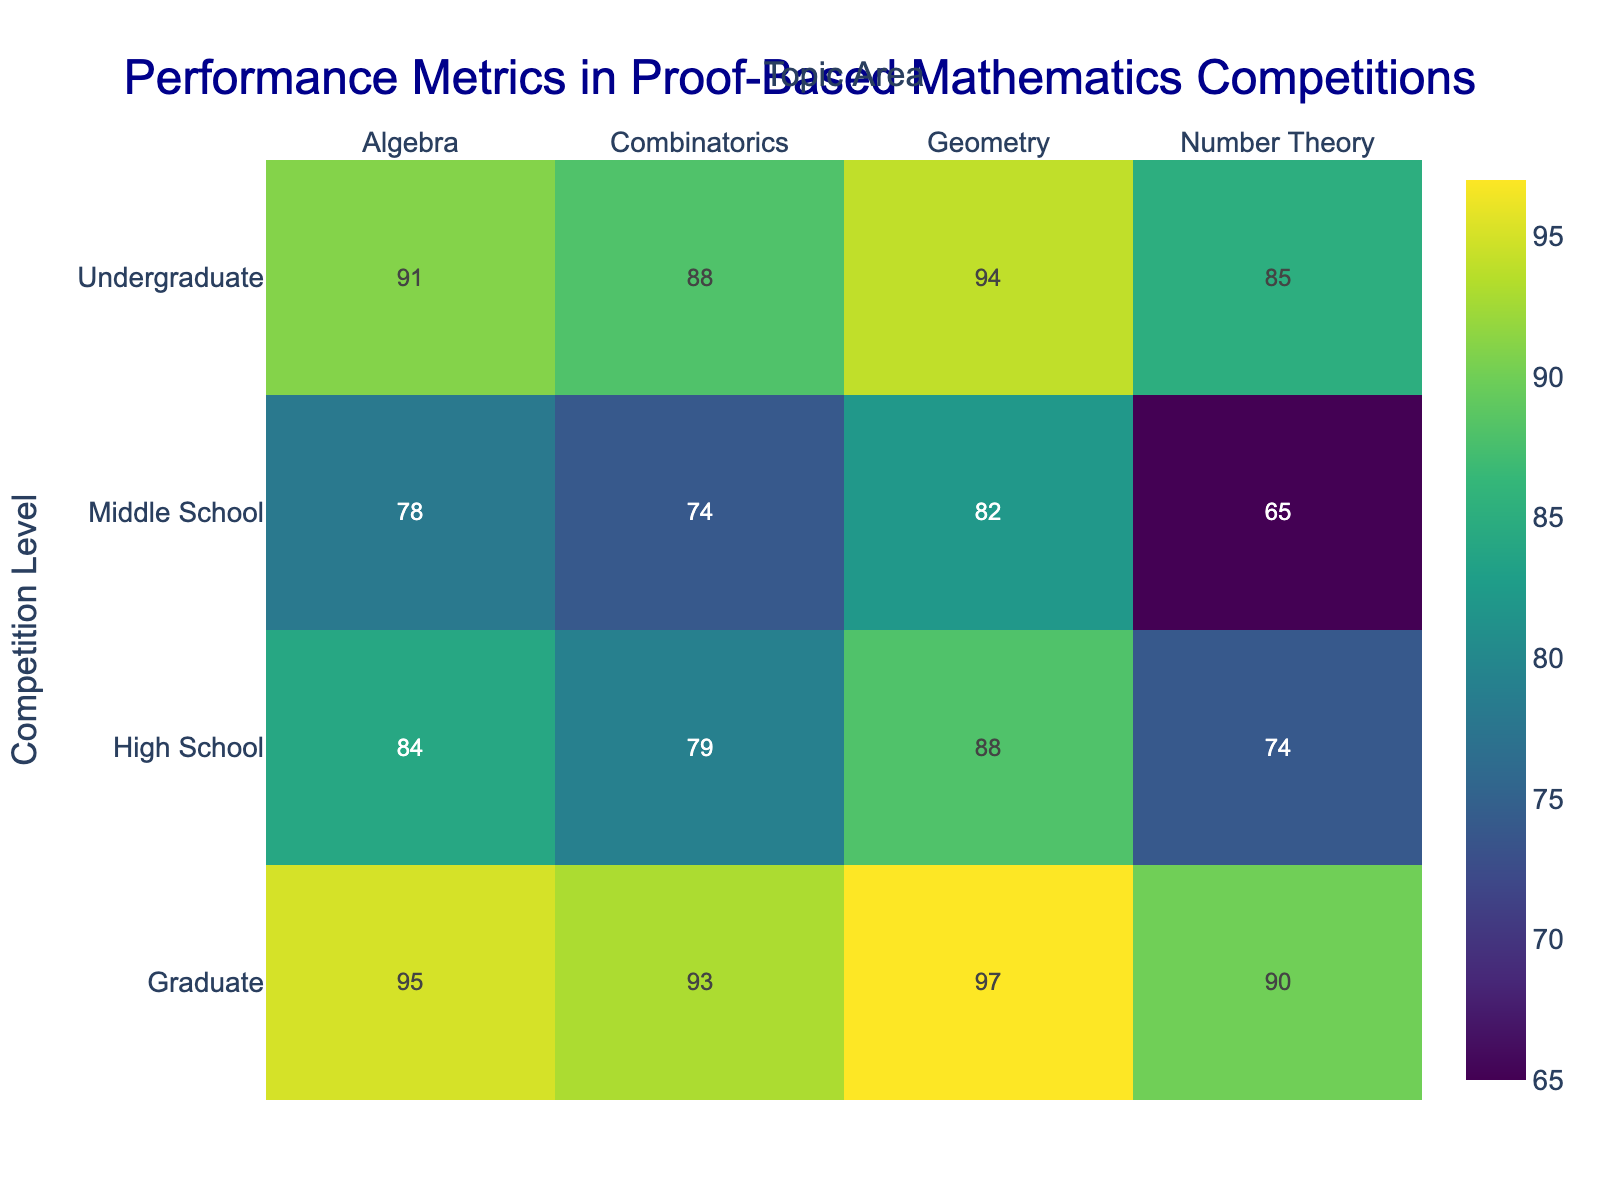What is the title of the heatmap? The title of the heatmap is displayed at the top center of the figure. It reads "Performance Metrics in Proof-Based Mathematics Competitions".
Answer: Performance Metrics in Proof-Based Mathematics Competitions Which Topic Area has the lowest average score at the Middle School level? At the Middle School level, the Topic Areas listed are Algebra, Geometry, Number Theory, and Combinatorics. The average scores are 78, 82, 65, and 74, respectively. The lowest score is in Number Theory with an average score of 65.
Answer: Number Theory What is the difference in the average scores for Geometry between the High School and Undergraduate levels? The average score for Geometry at the High School level is 88, and at the Undergraduate level, it is 94. The difference is 94 - 88 = 6.
Answer: 6 Which Topic Area at the Graduate level has the highest average score? At the Graduate level, the Topic Areas listed are Algebra, Geometry, Number Theory, and Combinatorics. The average scores are 95, 97, 90, and 93, respectively. The highest score is in Geometry with an average score of 97.
Answer: Geometry Compare the average scores for Combinatorics across all competition levels. Which level shows the highest improvement compared to the preceding level? The average scores for Combinatorics are: Middle School (74), High School (79), Undergraduate (88), and Graduate (93). The increments between levels are 5, 9, and 5. The highest improvement is seen when moving from High School to Undergraduate with an increment of 9.
Answer: High School to Undergraduate How many Topic Areas have an average score greater than 80 at the High School level? At the High School level, the Topic Areas and their average scores are: Algebra (84), Geometry (88), Number Theory (74), and Combinatorics (79). Three Topic Areas have an average score greater than 80.
Answer: Three What is the overall trend in average scores for Algebra from Middle School to Graduate level? The average scores for Algebra from Middle School to Graduate level are 78, 84, 91, and 95, respectively. The trend shows a consistent increase in the average scores as the competition level advances.
Answer: Increasing trend Is there any Topic Area where the Middle and High School average scores are equal? The average scores for Middle and High School levels across all Topic Areas (Algebra, Geometry, Number Theory, and Combinatorics) do not match for any Topic Area.
Answer: No What is the range of average scores for Number Theory across all competition levels? The average scores for Number Theory across Middle School, High School, Undergraduate, and Graduate levels are 65, 74, 85, and 90, respectively. The range is calculated as the difference between the highest and lowest values, i.e., 90 - 65 = 25.
Answer: 25 